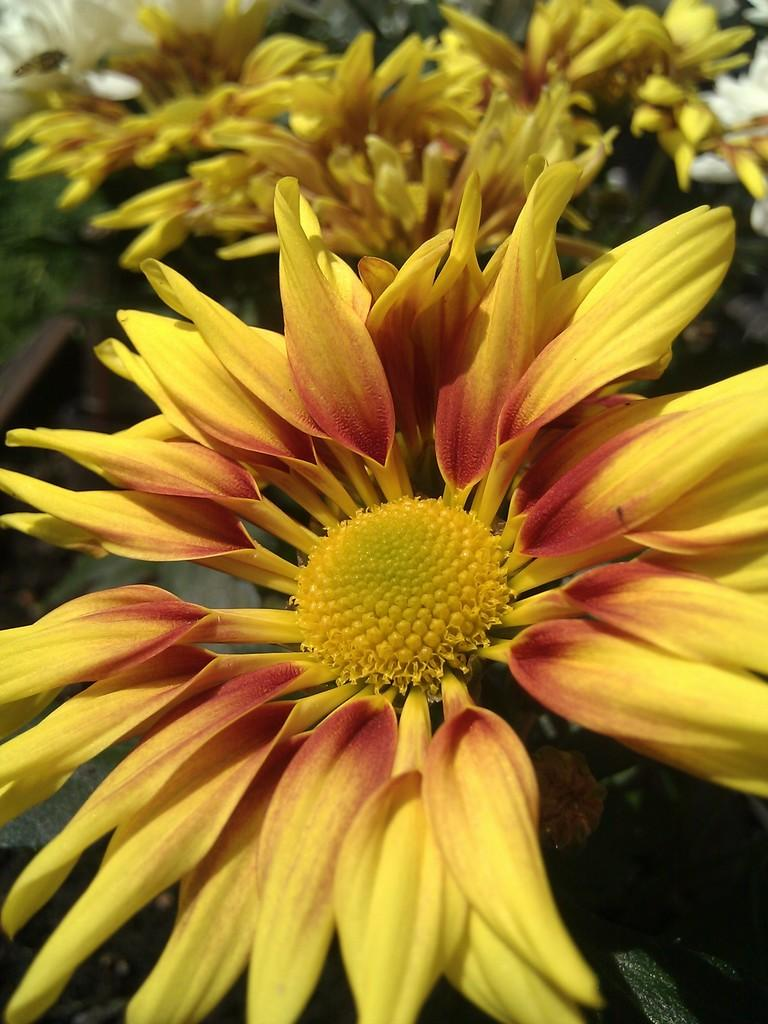What is the main subject of the image? There is a flower in the image. Can you describe the color of the flower? The flower is yellow and red in color. What can be seen in the background of the image? There are trees and flowers in the background of the image. What is the color of the flowers in the background? The flowers in the background are cream and yellow in color. What is the title of the book the flower is reading in the image? There is no book or reading activity depicted in the image; it features a flower and its colors. What type of juice is being served in the image? There is no juice or serving activity present in the image. 